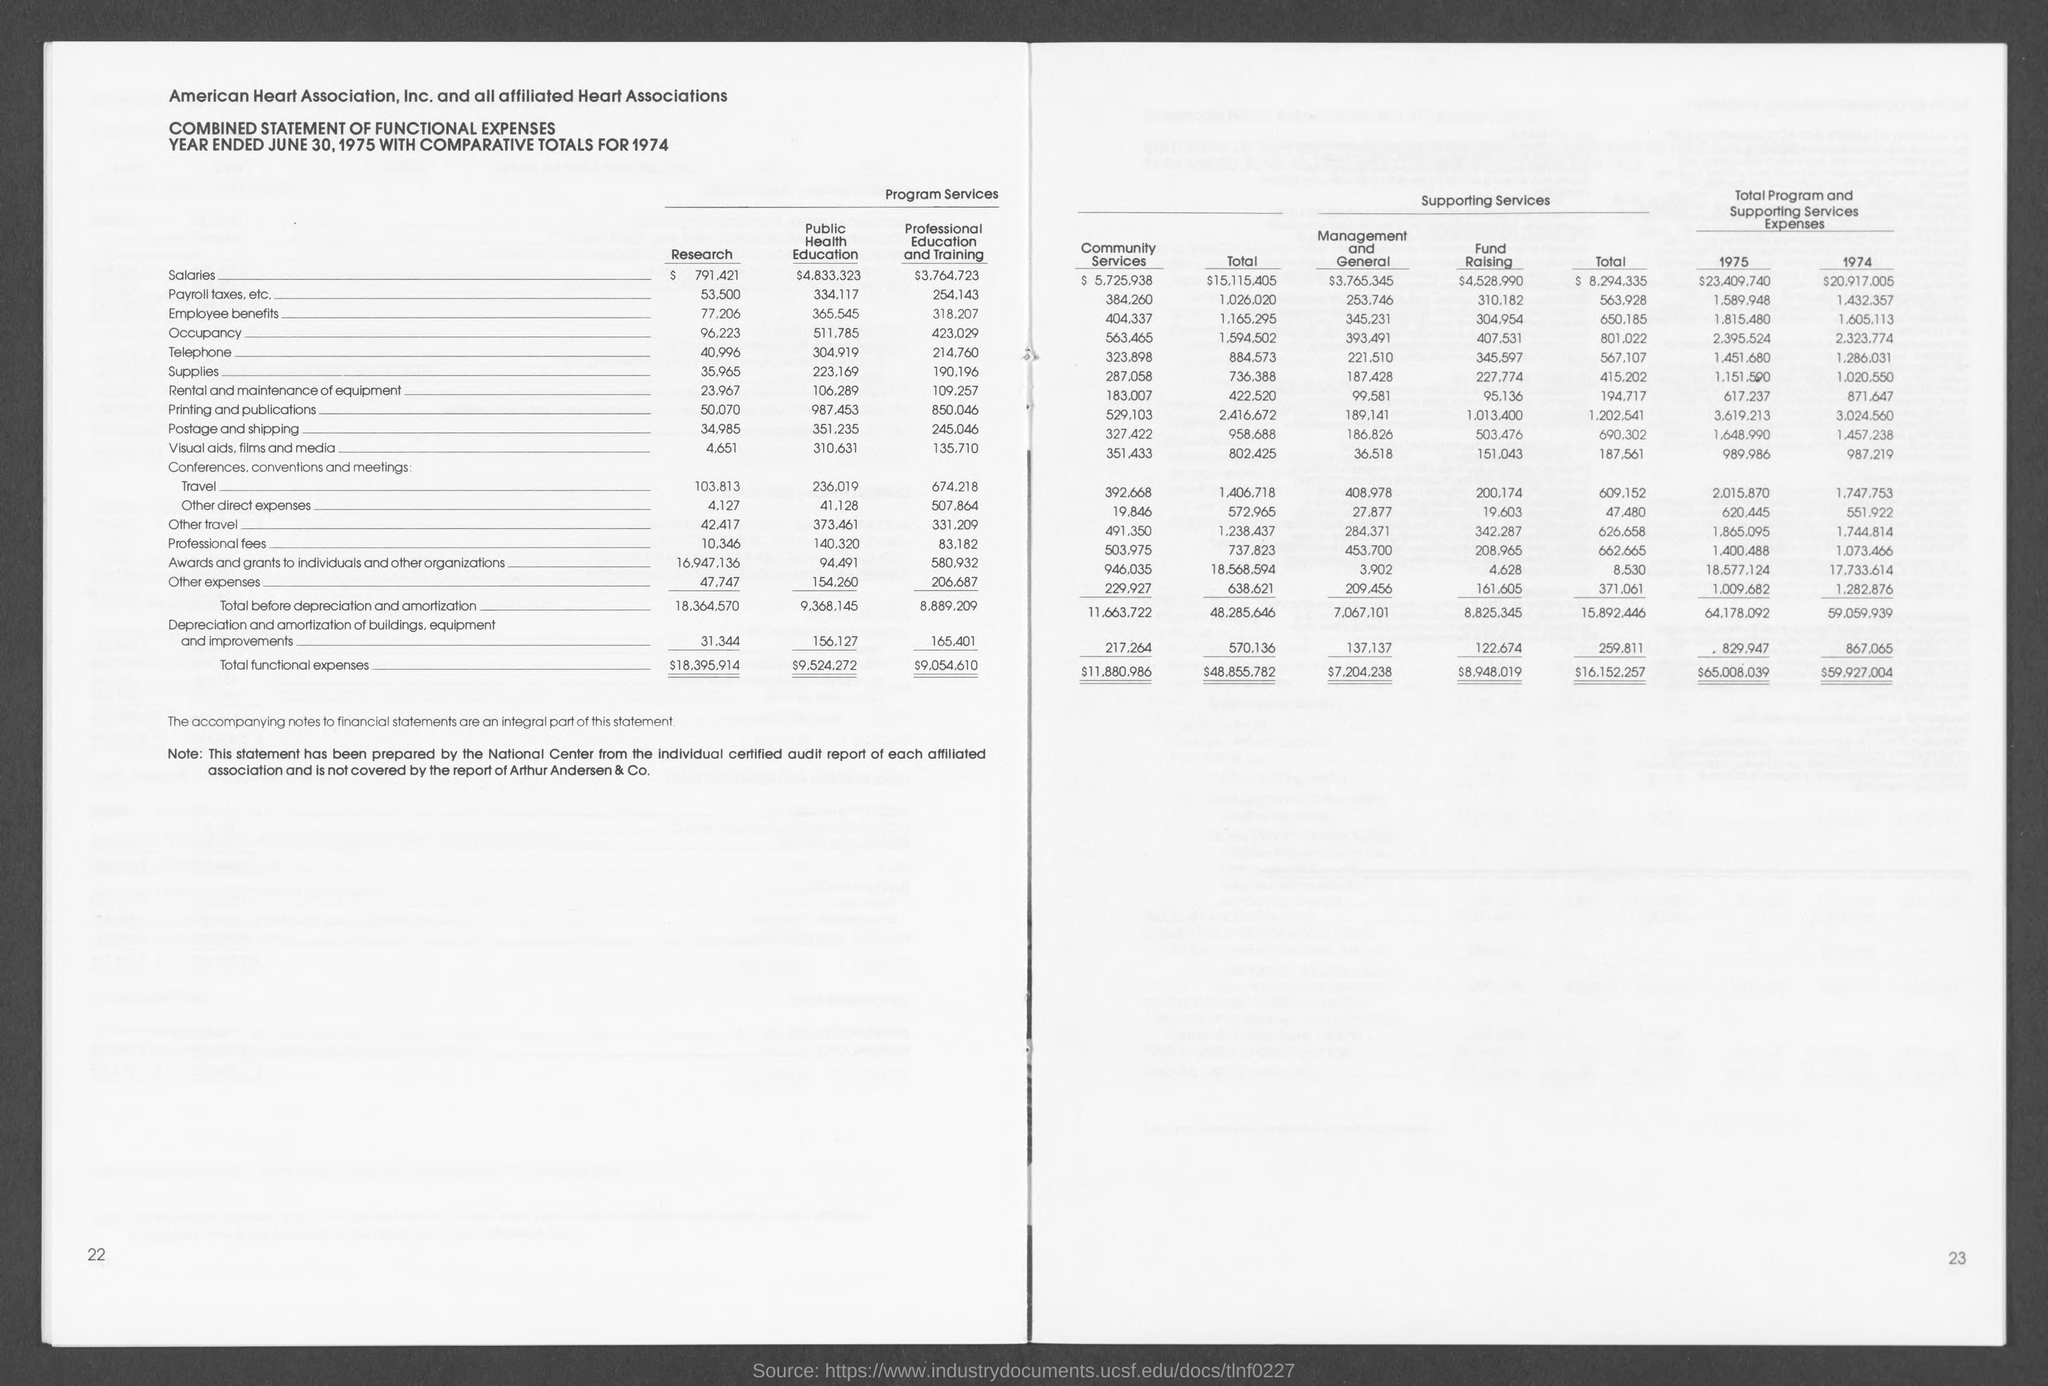Draw attention to some important aspects in this diagram. The total functional costs for public health education were $9,524,272. The total functional cost for professional education and training is $9,054.610. The total functional costs for research were $18,395.914. 